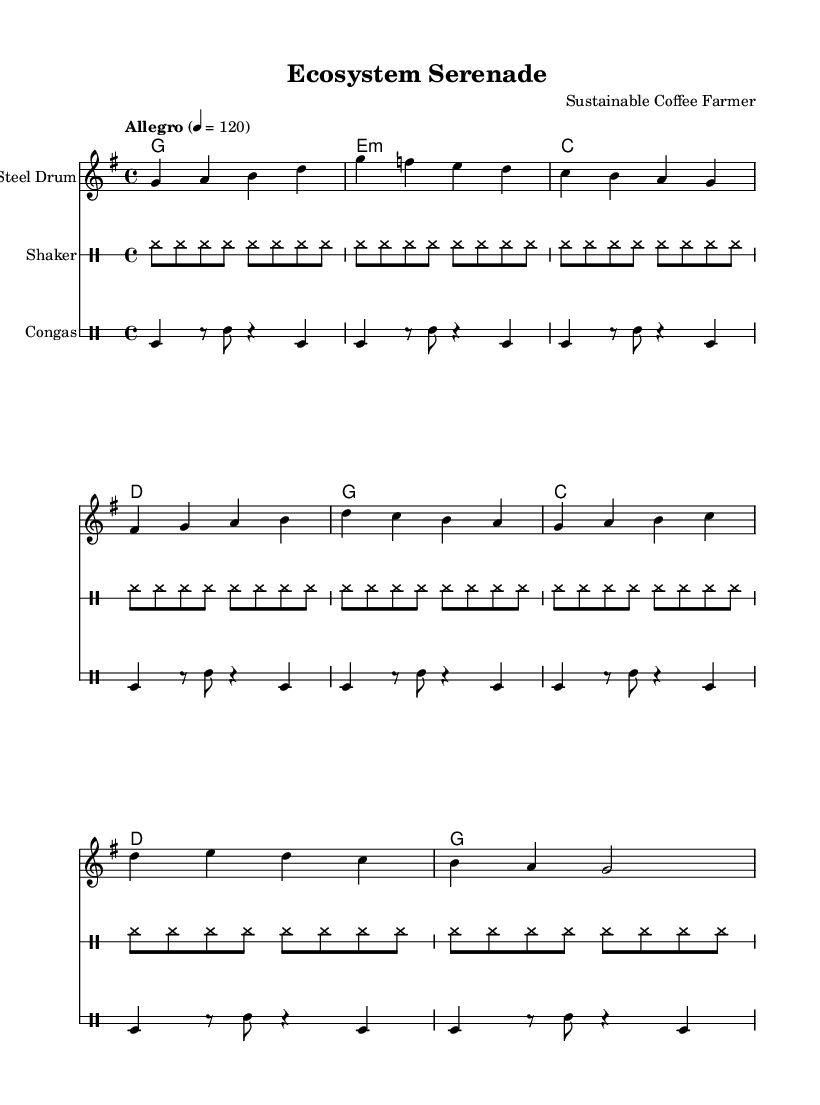What is the key signature of this music? The key signature is G major, which has one sharp (F#). This can be identified by looking for the key signature symbol at the beginning of the staff.
Answer: G major What is the time signature? The time signature is 4/4, as indicated at the beginning of the score. This means there are four beats in each measure, and a quarter note gets one beat.
Answer: 4/4 What is the tempo marking? The tempo marking indicates "Allegro" at 120 beats per minute, denoting a fast and lively pace for the piece. This is noted below the title in the score.
Answer: Allegro 4 = 120 How many measures are in the steel drum part? There are 8 measures in the steel drum part, as counted from the beginning to the end of the given notation.
Answer: 8 Which instruments are used in this score? The instruments used in this score are the steel drum, shaker, and congas. Each instrument is labeled above their respective staves.
Answer: Steel Drum, Shaker, Congas What type of harmony is present in this piece? The harmony consists of major and minor chords, specifically G major, E minor, C major, and D major, as seen in the chord symbols above the staff.
Answer: Major and minor chords How does the rhythm of the shaker part differ from the steel drum part? The shaker part consists of a continuous rhythm of eighth notes, while the steel drum part features varying rhythms with quarter and eighth notes. This creates a contrast between the steady and syncopated elements in the music.
Answer: Continuous eighth notes vs. varied rhythms 